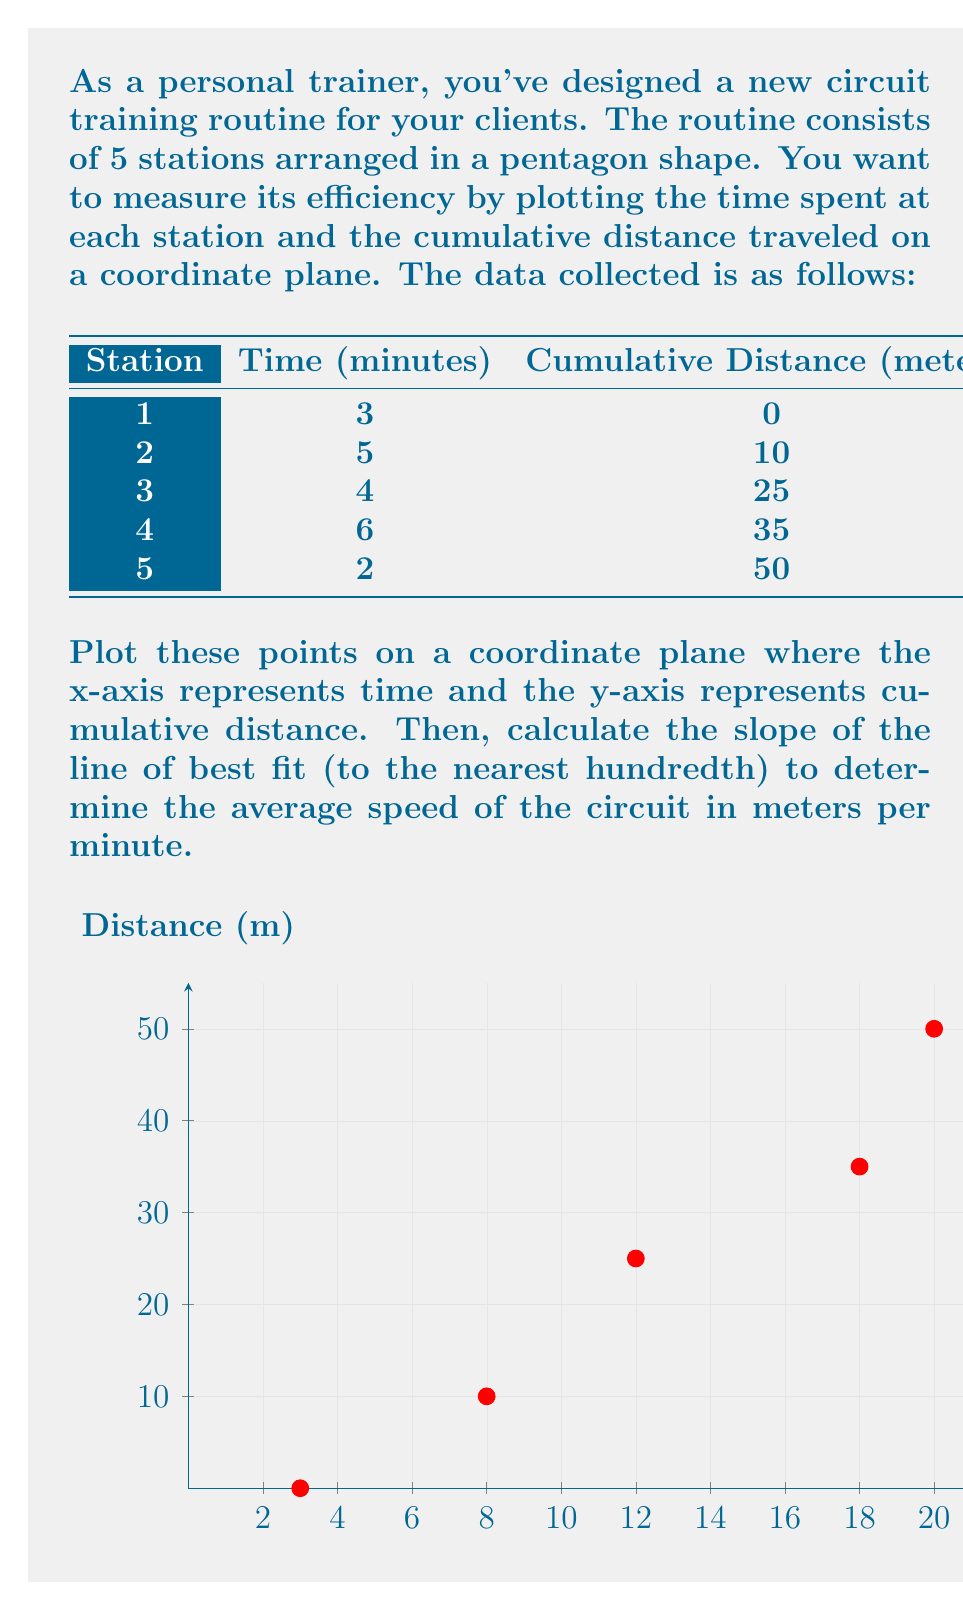What is the answer to this math problem? To solve this problem, we'll follow these steps:

1) Plot the points on the coordinate plane (already done in the question).

2) Calculate the slope of the line of best fit using the least squares method.

3) The slope formula for the line of best fit is:

   $$m = \frac{n\sum xy - \sum x \sum y}{n\sum x^2 - (\sum x)^2}$$

   Where $n$ is the number of points, $x$ are the time values, and $y$ are the distance values.

4) Let's calculate each component:

   $n = 5$
   $\sum x = 3 + 8 + 12 + 18 + 20 = 61$
   $\sum y = 0 + 10 + 25 + 35 + 50 = 120$
   $\sum xy = 3(0) + 8(10) + 12(25) + 18(35) + 20(50) = 2180$
   $\sum x^2 = 3^2 + 8^2 + 12^2 + 18^2 + 20^2 = 1013$

5) Now, let's substitute these values into the slope formula:

   $$m = \frac{5(2180) - 61(120)}{5(1013) - 61^2}$$

6) Simplify:

   $$m = \frac{10900 - 7320}{5065 - 3721} = \frac{3580}{1344} \approx 2.66$$

7) The slope represents the average speed in meters per minute.
Answer: 2.66 meters per minute 